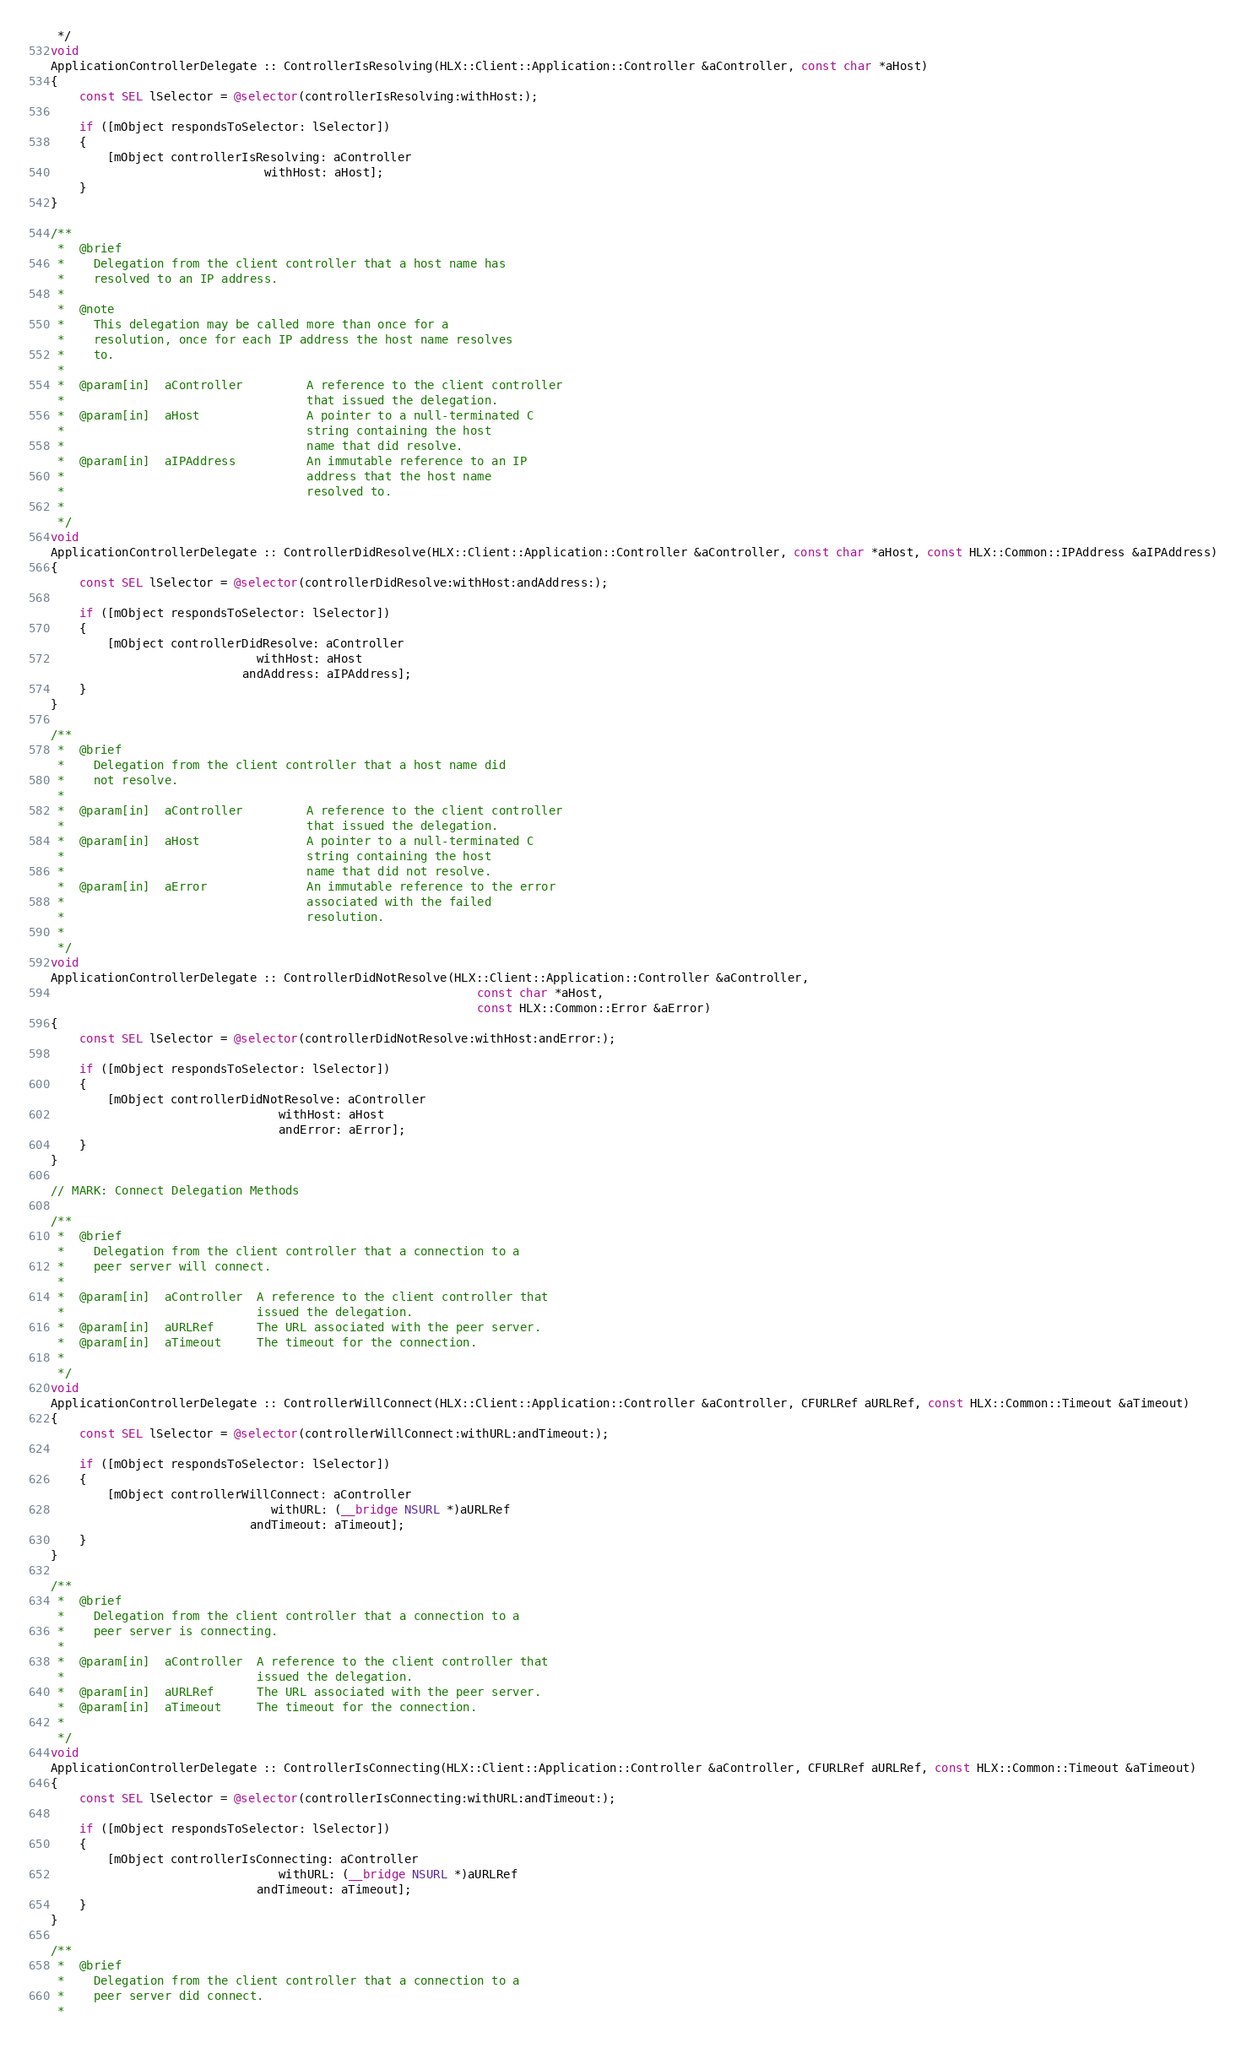<code> <loc_0><loc_0><loc_500><loc_500><_ObjectiveC_> */
void
ApplicationControllerDelegate :: ControllerIsResolving(HLX::Client::Application::Controller &aController, const char *aHost)
{
    const SEL lSelector = @selector(controllerIsResolving:withHost:);

    if ([mObject respondsToSelector: lSelector])
    {
        [mObject controllerIsResolving: aController
                              withHost: aHost];
    }
}

/**
 *  @brief
 *    Delegation from the client controller that a host name has
 *    resolved to an IP address.
 *
 *  @note
 *    This delegation may be called more than once for a
 *    resolution, once for each IP address the host name resolves
 *    to.
 *
 *  @param[in]  aController         A reference to the client controller
 *                                  that issued the delegation.
 *  @param[in]  aHost               A pointer to a null-terminated C
 *                                  string containing the host
 *                                  name that did resolve.
 *  @param[in]  aIPAddress          An immutable reference to an IP
 *                                  address that the host name
 *                                  resolved to.
 *
 */
void
ApplicationControllerDelegate :: ControllerDidResolve(HLX::Client::Application::Controller &aController, const char *aHost, const HLX::Common::IPAddress &aIPAddress)
{
    const SEL lSelector = @selector(controllerDidResolve:withHost:andAddress:);

    if ([mObject respondsToSelector: lSelector])
    {
        [mObject controllerDidResolve: aController
                             withHost: aHost
                           andAddress: aIPAddress];
    }
}

/**
 *  @brief
 *    Delegation from the client controller that a host name did
 *    not resolve.
 *
 *  @param[in]  aController         A reference to the client controller
 *                                  that issued the delegation.
 *  @param[in]  aHost               A pointer to a null-terminated C
 *                                  string containing the host
 *                                  name that did not resolve.
 *  @param[in]  aError              An immutable reference to the error
 *                                  associated with the failed
 *                                  resolution.
 *
 */
void
ApplicationControllerDelegate :: ControllerDidNotResolve(HLX::Client::Application::Controller &aController,
                                                            const char *aHost,
                                                            const HLX::Common::Error &aError)
{
    const SEL lSelector = @selector(controllerDidNotResolve:withHost:andError:);

    if ([mObject respondsToSelector: lSelector])
    {
        [mObject controllerDidNotResolve: aController
                                withHost: aHost
                                andError: aError];
    }
}

// MARK: Connect Delegation Methods

/**
 *  @brief
 *    Delegation from the client controller that a connection to a
 *    peer server will connect.
 *
 *  @param[in]  aController  A reference to the client controller that
 *                           issued the delegation.
 *  @param[in]  aURLRef      The URL associated with the peer server.
 *  @param[in]  aTimeout     The timeout for the connection.
 *
 */
void
ApplicationControllerDelegate :: ControllerWillConnect(HLX::Client::Application::Controller &aController, CFURLRef aURLRef, const HLX::Common::Timeout &aTimeout)
{
    const SEL lSelector = @selector(controllerWillConnect:withURL:andTimeout:);

    if ([mObject respondsToSelector: lSelector])
    {
        [mObject controllerWillConnect: aController
                               withURL: (__bridge NSURL *)aURLRef
                            andTimeout: aTimeout];
    }
}

/**
 *  @brief
 *    Delegation from the client controller that a connection to a
 *    peer server is connecting.
 *
 *  @param[in]  aController  A reference to the client controller that
 *                           issued the delegation.
 *  @param[in]  aURLRef      The URL associated with the peer server.
 *  @param[in]  aTimeout     The timeout for the connection.
 *
 */
void
ApplicationControllerDelegate :: ControllerIsConnecting(HLX::Client::Application::Controller &aController, CFURLRef aURLRef, const HLX::Common::Timeout &aTimeout)
{
    const SEL lSelector = @selector(controllerIsConnecting:withURL:andTimeout:);

    if ([mObject respondsToSelector: lSelector])
    {
        [mObject controllerIsConnecting: aController
                                withURL: (__bridge NSURL *)aURLRef
                             andTimeout: aTimeout];
    }
}

/**
 *  @brief
 *    Delegation from the client controller that a connection to a
 *    peer server did connect.
 *</code> 